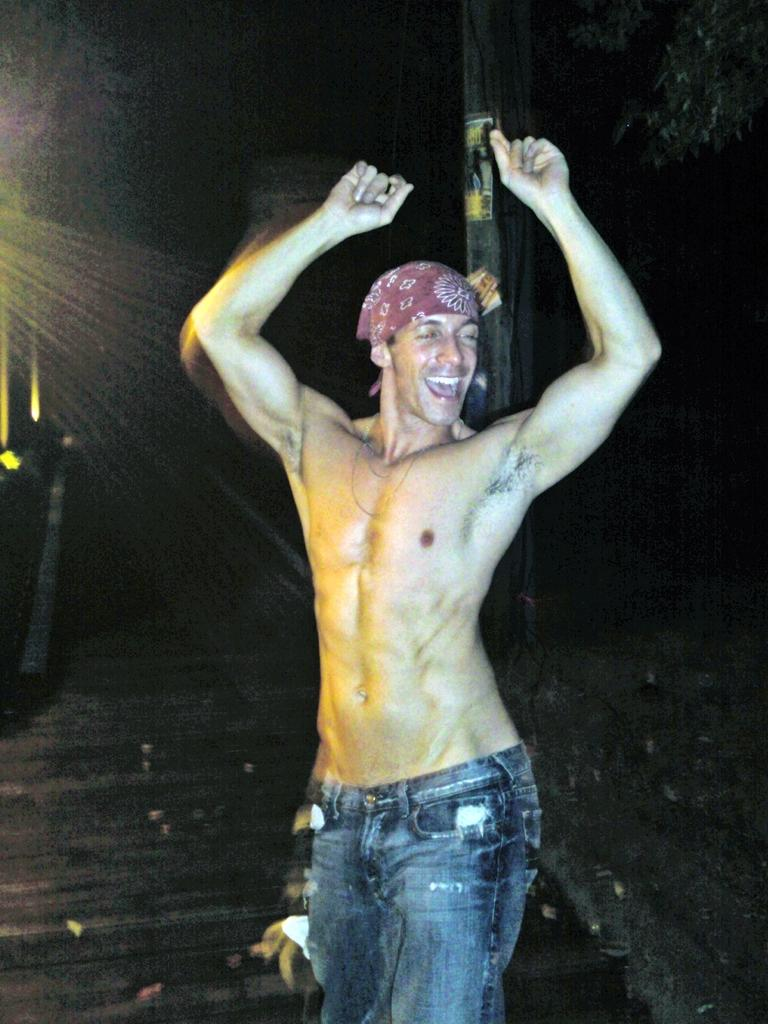Who is the main subject in the image? There is a man standing in the front of the image. What is the man doing in the image? The man is smiling. What can be seen in the background of the image? There is a pole in the background of the image. What type of vegetation is on the right side of the image? There are leaves on the right side of the image. What type of oven can be seen in the image? There is no oven present in the image. Can you tell me how many keys are visible in the image? There are no keys visible in the image. 